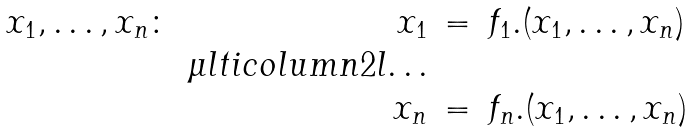Convert formula to latex. <formula><loc_0><loc_0><loc_500><loc_500>\begin{array} { r r c l } x _ { 1 } , \dots , x _ { n } \colon & x _ { 1 } & = & f _ { 1 } . ( x _ { 1 } , \dots , x _ { n } ) \\ & \mu l t i c o l u m n { 2 } { l } { \dots } \\ & x _ { n } & = & f _ { n } . ( x _ { 1 } , \dots , x _ { n } ) \end{array}</formula> 